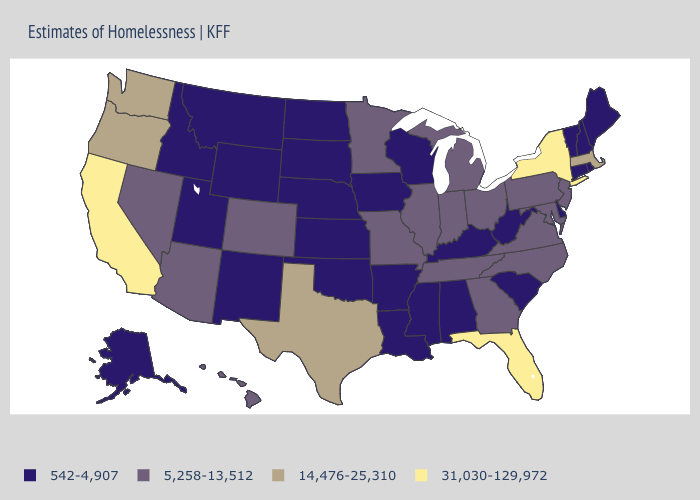What is the value of Arkansas?
Short answer required. 542-4,907. What is the value of Maryland?
Answer briefly. 5,258-13,512. What is the value of North Dakota?
Keep it brief. 542-4,907. Name the states that have a value in the range 5,258-13,512?
Give a very brief answer. Arizona, Colorado, Georgia, Hawaii, Illinois, Indiana, Maryland, Michigan, Minnesota, Missouri, Nevada, New Jersey, North Carolina, Ohio, Pennsylvania, Tennessee, Virginia. What is the lowest value in the USA?
Short answer required. 542-4,907. Among the states that border New Mexico , which have the lowest value?
Quick response, please. Oklahoma, Utah. What is the value of Nevada?
Quick response, please. 5,258-13,512. What is the value of Nevada?
Keep it brief. 5,258-13,512. Which states have the lowest value in the USA?
Short answer required. Alabama, Alaska, Arkansas, Connecticut, Delaware, Idaho, Iowa, Kansas, Kentucky, Louisiana, Maine, Mississippi, Montana, Nebraska, New Hampshire, New Mexico, North Dakota, Oklahoma, Rhode Island, South Carolina, South Dakota, Utah, Vermont, West Virginia, Wisconsin, Wyoming. Among the states that border Missouri , does Nebraska have the lowest value?
Concise answer only. Yes. What is the value of Massachusetts?
Be succinct. 14,476-25,310. Does the first symbol in the legend represent the smallest category?
Write a very short answer. Yes. What is the value of Alaska?
Be succinct. 542-4,907. How many symbols are there in the legend?
Answer briefly. 4. Does Alabama have the highest value in the South?
Concise answer only. No. 